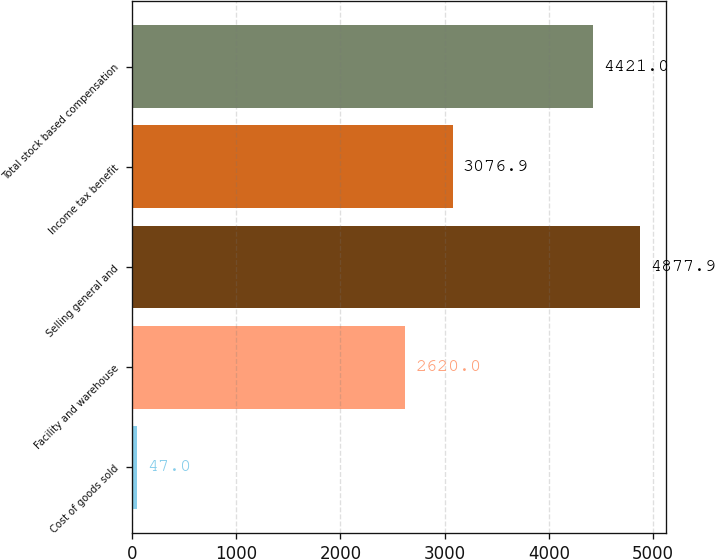Convert chart. <chart><loc_0><loc_0><loc_500><loc_500><bar_chart><fcel>Cost of goods sold<fcel>Facility and warehouse<fcel>Selling general and<fcel>Income tax benefit<fcel>Total stock based compensation<nl><fcel>47<fcel>2620<fcel>4877.9<fcel>3076.9<fcel>4421<nl></chart> 